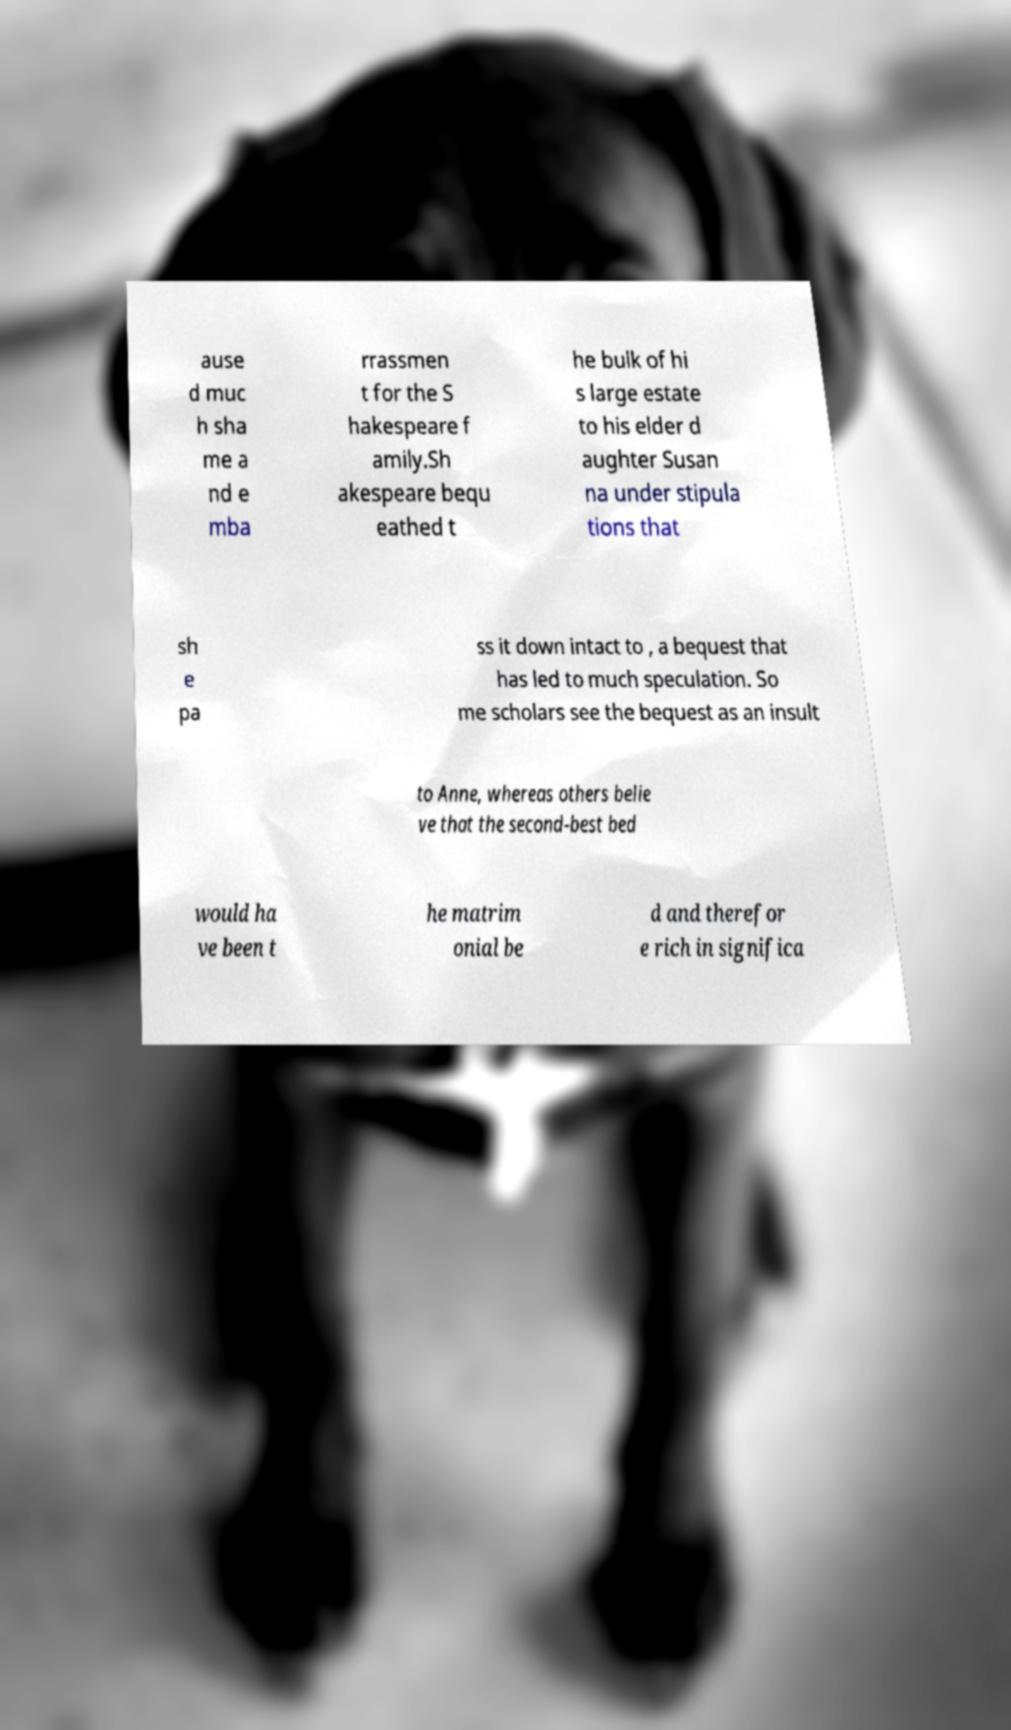Could you extract and type out the text from this image? ause d muc h sha me a nd e mba rrassmen t for the S hakespeare f amily.Sh akespeare bequ eathed t he bulk of hi s large estate to his elder d aughter Susan na under stipula tions that sh e pa ss it down intact to , a bequest that has led to much speculation. So me scholars see the bequest as an insult to Anne, whereas others belie ve that the second-best bed would ha ve been t he matrim onial be d and therefor e rich in significa 